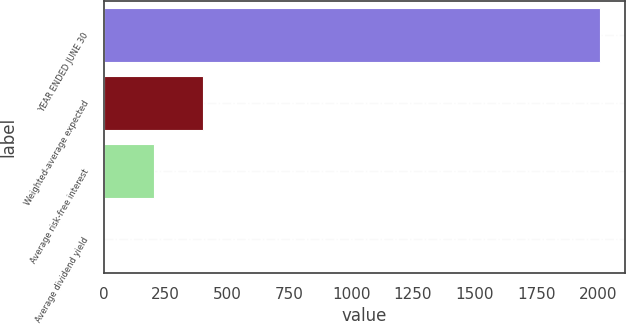<chart> <loc_0><loc_0><loc_500><loc_500><bar_chart><fcel>YEAR ENDED JUNE 30<fcel>Weighted-average expected<fcel>Average risk-free interest<fcel>Average dividend yield<nl><fcel>2007<fcel>402.36<fcel>201.78<fcel>1.2<nl></chart> 